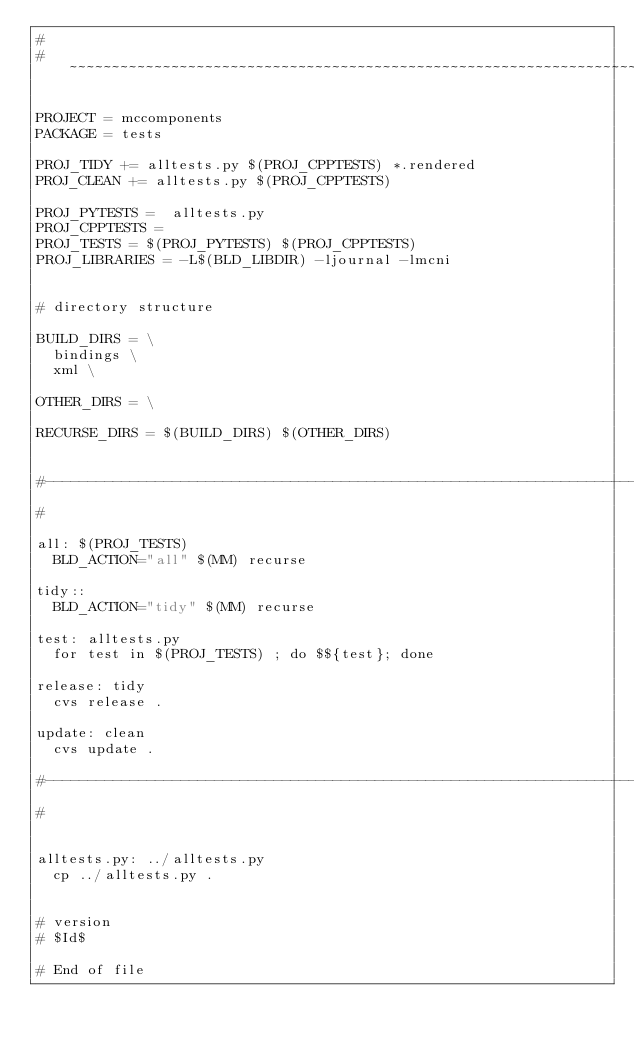<code> <loc_0><loc_0><loc_500><loc_500><_ObjectiveC_>#
# ~~~~~~~~~~~~~~~~~~~~~~~~~~~~~~~~~~~~~~~~~~~~~~~~~~~~~~~~~~~~~~~~~~~~~~~~~~~~~~~~

PROJECT = mccomponents
PACKAGE = tests

PROJ_TIDY += alltests.py $(PROJ_CPPTESTS) *.rendered
PROJ_CLEAN += alltests.py $(PROJ_CPPTESTS)

PROJ_PYTESTS =  alltests.py
PROJ_CPPTESTS = 
PROJ_TESTS = $(PROJ_PYTESTS) $(PROJ_CPPTESTS)
PROJ_LIBRARIES = -L$(BLD_LIBDIR) -ljournal -lmcni


# directory structure

BUILD_DIRS = \
	bindings \
	xml \

OTHER_DIRS = \

RECURSE_DIRS = $(BUILD_DIRS) $(OTHER_DIRS)


#--------------------------------------------------------------------------
#

all: $(PROJ_TESTS)
	BLD_ACTION="all" $(MM) recurse

tidy::
	BLD_ACTION="tidy" $(MM) recurse

test: alltests.py
	for test in $(PROJ_TESTS) ; do $${test}; done

release: tidy
	cvs release .

update: clean
	cvs update .

#--------------------------------------------------------------------------
#


alltests.py: ../alltests.py
	cp ../alltests.py .


# version
# $Id$

# End of file
</code> 